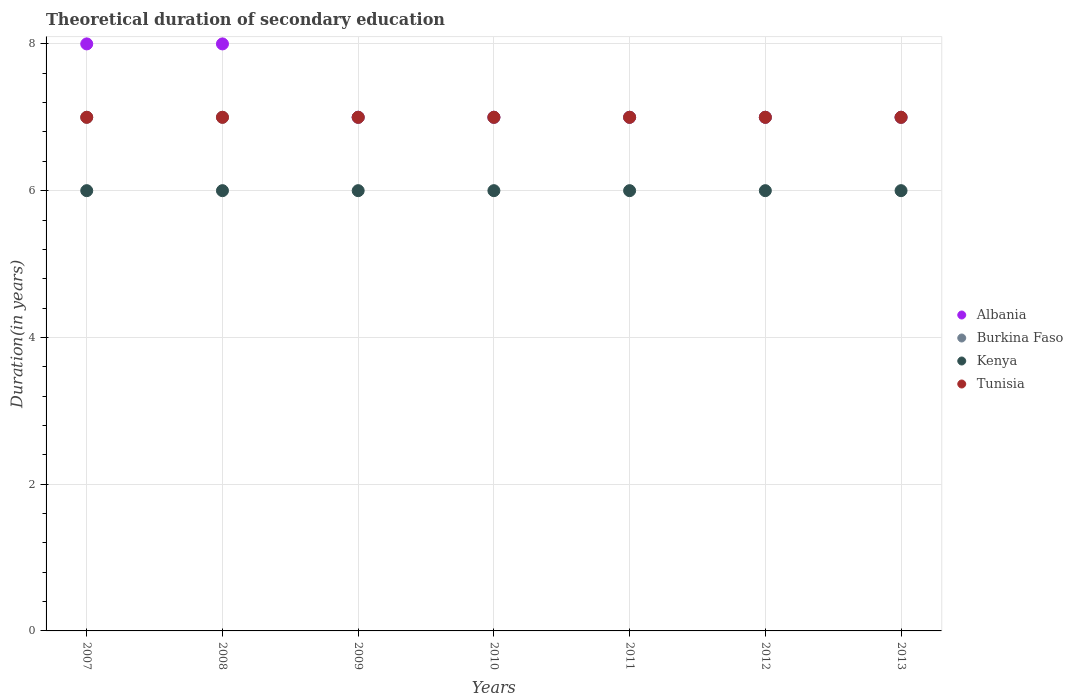What is the total theoretical duration of secondary education in Kenya in 2013?
Provide a short and direct response. 6. Across all years, what is the maximum total theoretical duration of secondary education in Albania?
Offer a very short reply. 8. Across all years, what is the minimum total theoretical duration of secondary education in Tunisia?
Keep it short and to the point. 7. What is the total total theoretical duration of secondary education in Burkina Faso in the graph?
Your answer should be very brief. 49. What is the difference between the total theoretical duration of secondary education in Burkina Faso in 2010 and the total theoretical duration of secondary education in Kenya in 2009?
Your answer should be compact. 1. In the year 2007, what is the difference between the total theoretical duration of secondary education in Tunisia and total theoretical duration of secondary education in Kenya?
Your answer should be compact. 1. In how many years, is the total theoretical duration of secondary education in Kenya greater than 6.4 years?
Offer a very short reply. 0. What is the ratio of the total theoretical duration of secondary education in Albania in 2008 to that in 2009?
Make the answer very short. 1.14. Is the total theoretical duration of secondary education in Kenya in 2008 less than that in 2010?
Your answer should be very brief. No. Is the difference between the total theoretical duration of secondary education in Tunisia in 2008 and 2013 greater than the difference between the total theoretical duration of secondary education in Kenya in 2008 and 2013?
Ensure brevity in your answer.  No. What is the difference between the highest and the second highest total theoretical duration of secondary education in Albania?
Offer a terse response. 0. What is the difference between the highest and the lowest total theoretical duration of secondary education in Tunisia?
Ensure brevity in your answer.  0. Is it the case that in every year, the sum of the total theoretical duration of secondary education in Albania and total theoretical duration of secondary education in Tunisia  is greater than the sum of total theoretical duration of secondary education in Kenya and total theoretical duration of secondary education in Burkina Faso?
Your response must be concise. Yes. Is the total theoretical duration of secondary education in Albania strictly less than the total theoretical duration of secondary education in Burkina Faso over the years?
Make the answer very short. No. How many dotlines are there?
Your answer should be very brief. 4. How many years are there in the graph?
Offer a terse response. 7. Are the values on the major ticks of Y-axis written in scientific E-notation?
Provide a short and direct response. No. Does the graph contain any zero values?
Make the answer very short. No. Does the graph contain grids?
Offer a terse response. Yes. What is the title of the graph?
Offer a very short reply. Theoretical duration of secondary education. What is the label or title of the Y-axis?
Provide a succinct answer. Duration(in years). What is the Duration(in years) in Burkina Faso in 2007?
Make the answer very short. 7. What is the Duration(in years) of Tunisia in 2007?
Provide a succinct answer. 7. What is the Duration(in years) of Albania in 2008?
Offer a very short reply. 8. What is the Duration(in years) of Burkina Faso in 2008?
Your answer should be very brief. 7. What is the Duration(in years) of Kenya in 2008?
Your response must be concise. 6. What is the Duration(in years) of Burkina Faso in 2010?
Offer a terse response. 7. What is the Duration(in years) of Kenya in 2010?
Offer a very short reply. 6. What is the Duration(in years) of Tunisia in 2010?
Provide a short and direct response. 7. What is the Duration(in years) of Burkina Faso in 2011?
Your answer should be compact. 7. What is the Duration(in years) of Burkina Faso in 2012?
Make the answer very short. 7. What is the Duration(in years) in Kenya in 2012?
Make the answer very short. 6. What is the Duration(in years) of Albania in 2013?
Provide a short and direct response. 7. What is the Duration(in years) in Burkina Faso in 2013?
Make the answer very short. 7. What is the Duration(in years) of Kenya in 2013?
Make the answer very short. 6. Across all years, what is the maximum Duration(in years) of Albania?
Provide a succinct answer. 8. Across all years, what is the maximum Duration(in years) in Burkina Faso?
Offer a terse response. 7. Across all years, what is the minimum Duration(in years) of Burkina Faso?
Keep it short and to the point. 7. Across all years, what is the minimum Duration(in years) of Kenya?
Your response must be concise. 6. Across all years, what is the minimum Duration(in years) of Tunisia?
Your response must be concise. 7. What is the total Duration(in years) of Albania in the graph?
Make the answer very short. 51. What is the total Duration(in years) of Tunisia in the graph?
Keep it short and to the point. 49. What is the difference between the Duration(in years) in Tunisia in 2007 and that in 2008?
Give a very brief answer. 0. What is the difference between the Duration(in years) of Burkina Faso in 2007 and that in 2009?
Provide a succinct answer. 0. What is the difference between the Duration(in years) of Kenya in 2007 and that in 2009?
Offer a terse response. 0. What is the difference between the Duration(in years) of Kenya in 2007 and that in 2010?
Keep it short and to the point. 0. What is the difference between the Duration(in years) of Burkina Faso in 2007 and that in 2012?
Your response must be concise. 0. What is the difference between the Duration(in years) of Kenya in 2007 and that in 2012?
Your response must be concise. 0. What is the difference between the Duration(in years) of Albania in 2007 and that in 2013?
Ensure brevity in your answer.  1. What is the difference between the Duration(in years) in Kenya in 2007 and that in 2013?
Your response must be concise. 0. What is the difference between the Duration(in years) in Tunisia in 2007 and that in 2013?
Your answer should be very brief. 0. What is the difference between the Duration(in years) of Albania in 2008 and that in 2009?
Ensure brevity in your answer.  1. What is the difference between the Duration(in years) in Burkina Faso in 2008 and that in 2009?
Ensure brevity in your answer.  0. What is the difference between the Duration(in years) of Tunisia in 2008 and that in 2009?
Your answer should be very brief. 0. What is the difference between the Duration(in years) of Albania in 2008 and that in 2011?
Your answer should be compact. 1. What is the difference between the Duration(in years) of Burkina Faso in 2008 and that in 2011?
Offer a terse response. 0. What is the difference between the Duration(in years) of Kenya in 2008 and that in 2011?
Make the answer very short. 0. What is the difference between the Duration(in years) in Tunisia in 2008 and that in 2011?
Your response must be concise. 0. What is the difference between the Duration(in years) in Albania in 2008 and that in 2012?
Make the answer very short. 1. What is the difference between the Duration(in years) of Burkina Faso in 2008 and that in 2012?
Provide a short and direct response. 0. What is the difference between the Duration(in years) in Kenya in 2008 and that in 2012?
Keep it short and to the point. 0. What is the difference between the Duration(in years) of Tunisia in 2008 and that in 2012?
Your response must be concise. 0. What is the difference between the Duration(in years) of Albania in 2008 and that in 2013?
Offer a terse response. 1. What is the difference between the Duration(in years) in Burkina Faso in 2008 and that in 2013?
Keep it short and to the point. 0. What is the difference between the Duration(in years) of Kenya in 2008 and that in 2013?
Offer a very short reply. 0. What is the difference between the Duration(in years) in Tunisia in 2008 and that in 2013?
Keep it short and to the point. 0. What is the difference between the Duration(in years) in Albania in 2009 and that in 2010?
Your answer should be compact. 0. What is the difference between the Duration(in years) in Burkina Faso in 2009 and that in 2010?
Offer a very short reply. 0. What is the difference between the Duration(in years) in Tunisia in 2009 and that in 2010?
Your response must be concise. 0. What is the difference between the Duration(in years) in Kenya in 2009 and that in 2011?
Ensure brevity in your answer.  0. What is the difference between the Duration(in years) in Tunisia in 2009 and that in 2011?
Make the answer very short. 0. What is the difference between the Duration(in years) of Albania in 2009 and that in 2012?
Provide a short and direct response. 0. What is the difference between the Duration(in years) of Burkina Faso in 2009 and that in 2012?
Offer a terse response. 0. What is the difference between the Duration(in years) in Kenya in 2009 and that in 2012?
Your answer should be compact. 0. What is the difference between the Duration(in years) in Albania in 2009 and that in 2013?
Keep it short and to the point. 0. What is the difference between the Duration(in years) in Tunisia in 2009 and that in 2013?
Your response must be concise. 0. What is the difference between the Duration(in years) of Albania in 2010 and that in 2011?
Make the answer very short. 0. What is the difference between the Duration(in years) in Kenya in 2010 and that in 2011?
Give a very brief answer. 0. What is the difference between the Duration(in years) of Albania in 2010 and that in 2012?
Make the answer very short. 0. What is the difference between the Duration(in years) in Kenya in 2010 and that in 2012?
Give a very brief answer. 0. What is the difference between the Duration(in years) of Tunisia in 2010 and that in 2012?
Your answer should be compact. 0. What is the difference between the Duration(in years) of Albania in 2010 and that in 2013?
Offer a very short reply. 0. What is the difference between the Duration(in years) in Burkina Faso in 2010 and that in 2013?
Keep it short and to the point. 0. What is the difference between the Duration(in years) of Tunisia in 2010 and that in 2013?
Offer a terse response. 0. What is the difference between the Duration(in years) of Albania in 2011 and that in 2012?
Your answer should be compact. 0. What is the difference between the Duration(in years) in Burkina Faso in 2011 and that in 2012?
Your answer should be compact. 0. What is the difference between the Duration(in years) of Tunisia in 2011 and that in 2012?
Offer a very short reply. 0. What is the difference between the Duration(in years) of Albania in 2011 and that in 2013?
Keep it short and to the point. 0. What is the difference between the Duration(in years) in Kenya in 2011 and that in 2013?
Make the answer very short. 0. What is the difference between the Duration(in years) in Burkina Faso in 2012 and that in 2013?
Provide a short and direct response. 0. What is the difference between the Duration(in years) in Albania in 2007 and the Duration(in years) in Burkina Faso in 2008?
Make the answer very short. 1. What is the difference between the Duration(in years) of Burkina Faso in 2007 and the Duration(in years) of Tunisia in 2008?
Offer a terse response. 0. What is the difference between the Duration(in years) of Albania in 2007 and the Duration(in years) of Kenya in 2009?
Your answer should be compact. 2. What is the difference between the Duration(in years) in Burkina Faso in 2007 and the Duration(in years) in Kenya in 2009?
Make the answer very short. 1. What is the difference between the Duration(in years) in Albania in 2007 and the Duration(in years) in Burkina Faso in 2010?
Your answer should be very brief. 1. What is the difference between the Duration(in years) of Albania in 2007 and the Duration(in years) of Kenya in 2010?
Ensure brevity in your answer.  2. What is the difference between the Duration(in years) in Albania in 2007 and the Duration(in years) in Tunisia in 2010?
Your response must be concise. 1. What is the difference between the Duration(in years) of Burkina Faso in 2007 and the Duration(in years) of Kenya in 2010?
Your answer should be compact. 1. What is the difference between the Duration(in years) of Kenya in 2007 and the Duration(in years) of Tunisia in 2010?
Make the answer very short. -1. What is the difference between the Duration(in years) in Albania in 2007 and the Duration(in years) in Burkina Faso in 2011?
Offer a terse response. 1. What is the difference between the Duration(in years) in Albania in 2007 and the Duration(in years) in Kenya in 2011?
Give a very brief answer. 2. What is the difference between the Duration(in years) of Burkina Faso in 2007 and the Duration(in years) of Kenya in 2011?
Offer a terse response. 1. What is the difference between the Duration(in years) of Kenya in 2007 and the Duration(in years) of Tunisia in 2011?
Provide a short and direct response. -1. What is the difference between the Duration(in years) in Albania in 2007 and the Duration(in years) in Burkina Faso in 2012?
Ensure brevity in your answer.  1. What is the difference between the Duration(in years) of Albania in 2007 and the Duration(in years) of Kenya in 2012?
Provide a short and direct response. 2. What is the difference between the Duration(in years) of Albania in 2007 and the Duration(in years) of Tunisia in 2012?
Provide a short and direct response. 1. What is the difference between the Duration(in years) in Burkina Faso in 2007 and the Duration(in years) in Kenya in 2012?
Offer a terse response. 1. What is the difference between the Duration(in years) of Albania in 2007 and the Duration(in years) of Burkina Faso in 2013?
Your response must be concise. 1. What is the difference between the Duration(in years) in Kenya in 2007 and the Duration(in years) in Tunisia in 2013?
Provide a short and direct response. -1. What is the difference between the Duration(in years) in Albania in 2008 and the Duration(in years) in Kenya in 2009?
Make the answer very short. 2. What is the difference between the Duration(in years) of Albania in 2008 and the Duration(in years) of Tunisia in 2009?
Give a very brief answer. 1. What is the difference between the Duration(in years) in Burkina Faso in 2008 and the Duration(in years) in Tunisia in 2009?
Provide a succinct answer. 0. What is the difference between the Duration(in years) in Albania in 2008 and the Duration(in years) in Burkina Faso in 2010?
Provide a short and direct response. 1. What is the difference between the Duration(in years) in Burkina Faso in 2008 and the Duration(in years) in Kenya in 2010?
Offer a terse response. 1. What is the difference between the Duration(in years) in Kenya in 2008 and the Duration(in years) in Tunisia in 2010?
Your answer should be very brief. -1. What is the difference between the Duration(in years) of Albania in 2008 and the Duration(in years) of Kenya in 2011?
Make the answer very short. 2. What is the difference between the Duration(in years) in Burkina Faso in 2008 and the Duration(in years) in Kenya in 2011?
Offer a very short reply. 1. What is the difference between the Duration(in years) in Albania in 2008 and the Duration(in years) in Kenya in 2012?
Your answer should be very brief. 2. What is the difference between the Duration(in years) of Kenya in 2008 and the Duration(in years) of Tunisia in 2012?
Provide a succinct answer. -1. What is the difference between the Duration(in years) in Albania in 2008 and the Duration(in years) in Tunisia in 2013?
Make the answer very short. 1. What is the difference between the Duration(in years) of Kenya in 2008 and the Duration(in years) of Tunisia in 2013?
Offer a terse response. -1. What is the difference between the Duration(in years) of Albania in 2009 and the Duration(in years) of Kenya in 2010?
Keep it short and to the point. 1. What is the difference between the Duration(in years) in Albania in 2009 and the Duration(in years) in Tunisia in 2010?
Offer a terse response. 0. What is the difference between the Duration(in years) in Burkina Faso in 2009 and the Duration(in years) in Tunisia in 2010?
Your response must be concise. 0. What is the difference between the Duration(in years) in Albania in 2009 and the Duration(in years) in Burkina Faso in 2011?
Your answer should be very brief. 0. What is the difference between the Duration(in years) of Albania in 2009 and the Duration(in years) of Kenya in 2011?
Give a very brief answer. 1. What is the difference between the Duration(in years) of Burkina Faso in 2009 and the Duration(in years) of Kenya in 2011?
Provide a succinct answer. 1. What is the difference between the Duration(in years) of Burkina Faso in 2009 and the Duration(in years) of Tunisia in 2011?
Your answer should be compact. 0. What is the difference between the Duration(in years) of Kenya in 2009 and the Duration(in years) of Tunisia in 2011?
Your answer should be very brief. -1. What is the difference between the Duration(in years) of Albania in 2009 and the Duration(in years) of Kenya in 2012?
Your response must be concise. 1. What is the difference between the Duration(in years) of Albania in 2009 and the Duration(in years) of Tunisia in 2012?
Offer a very short reply. 0. What is the difference between the Duration(in years) of Burkina Faso in 2009 and the Duration(in years) of Tunisia in 2012?
Your answer should be compact. 0. What is the difference between the Duration(in years) of Albania in 2009 and the Duration(in years) of Burkina Faso in 2013?
Your answer should be very brief. 0. What is the difference between the Duration(in years) in Albania in 2009 and the Duration(in years) in Tunisia in 2013?
Keep it short and to the point. 0. What is the difference between the Duration(in years) of Burkina Faso in 2009 and the Duration(in years) of Kenya in 2013?
Offer a very short reply. 1. What is the difference between the Duration(in years) of Burkina Faso in 2009 and the Duration(in years) of Tunisia in 2013?
Provide a short and direct response. 0. What is the difference between the Duration(in years) in Albania in 2010 and the Duration(in years) in Burkina Faso in 2011?
Provide a short and direct response. 0. What is the difference between the Duration(in years) of Albania in 2010 and the Duration(in years) of Kenya in 2011?
Provide a succinct answer. 1. What is the difference between the Duration(in years) of Burkina Faso in 2010 and the Duration(in years) of Tunisia in 2011?
Ensure brevity in your answer.  0. What is the difference between the Duration(in years) of Albania in 2010 and the Duration(in years) of Burkina Faso in 2012?
Keep it short and to the point. 0. What is the difference between the Duration(in years) of Burkina Faso in 2010 and the Duration(in years) of Tunisia in 2012?
Your response must be concise. 0. What is the difference between the Duration(in years) in Albania in 2010 and the Duration(in years) in Burkina Faso in 2013?
Your answer should be compact. 0. What is the difference between the Duration(in years) of Burkina Faso in 2010 and the Duration(in years) of Kenya in 2013?
Provide a short and direct response. 1. What is the difference between the Duration(in years) in Burkina Faso in 2010 and the Duration(in years) in Tunisia in 2013?
Ensure brevity in your answer.  0. What is the difference between the Duration(in years) of Albania in 2011 and the Duration(in years) of Burkina Faso in 2012?
Make the answer very short. 0. What is the difference between the Duration(in years) in Albania in 2011 and the Duration(in years) in Tunisia in 2012?
Ensure brevity in your answer.  0. What is the difference between the Duration(in years) in Burkina Faso in 2011 and the Duration(in years) in Kenya in 2012?
Your response must be concise. 1. What is the difference between the Duration(in years) of Burkina Faso in 2011 and the Duration(in years) of Tunisia in 2012?
Your answer should be compact. 0. What is the difference between the Duration(in years) in Albania in 2011 and the Duration(in years) in Tunisia in 2013?
Provide a short and direct response. 0. What is the difference between the Duration(in years) in Burkina Faso in 2011 and the Duration(in years) in Tunisia in 2013?
Provide a succinct answer. 0. What is the difference between the Duration(in years) of Albania in 2012 and the Duration(in years) of Burkina Faso in 2013?
Your answer should be very brief. 0. What is the difference between the Duration(in years) in Albania in 2012 and the Duration(in years) in Kenya in 2013?
Make the answer very short. 1. What is the difference between the Duration(in years) of Burkina Faso in 2012 and the Duration(in years) of Tunisia in 2013?
Provide a succinct answer. 0. What is the difference between the Duration(in years) in Kenya in 2012 and the Duration(in years) in Tunisia in 2013?
Your answer should be very brief. -1. What is the average Duration(in years) in Albania per year?
Provide a short and direct response. 7.29. What is the average Duration(in years) in Burkina Faso per year?
Your response must be concise. 7. What is the average Duration(in years) in Tunisia per year?
Provide a succinct answer. 7. In the year 2007, what is the difference between the Duration(in years) in Albania and Duration(in years) in Kenya?
Ensure brevity in your answer.  2. In the year 2007, what is the difference between the Duration(in years) in Albania and Duration(in years) in Tunisia?
Ensure brevity in your answer.  1. In the year 2007, what is the difference between the Duration(in years) of Burkina Faso and Duration(in years) of Kenya?
Your answer should be compact. 1. In the year 2008, what is the difference between the Duration(in years) of Albania and Duration(in years) of Burkina Faso?
Your answer should be very brief. 1. In the year 2008, what is the difference between the Duration(in years) of Albania and Duration(in years) of Tunisia?
Offer a terse response. 1. In the year 2008, what is the difference between the Duration(in years) of Burkina Faso and Duration(in years) of Kenya?
Your answer should be compact. 1. In the year 2008, what is the difference between the Duration(in years) in Burkina Faso and Duration(in years) in Tunisia?
Offer a very short reply. 0. In the year 2009, what is the difference between the Duration(in years) in Albania and Duration(in years) in Kenya?
Your answer should be compact. 1. In the year 2009, what is the difference between the Duration(in years) in Burkina Faso and Duration(in years) in Kenya?
Your answer should be compact. 1. In the year 2009, what is the difference between the Duration(in years) of Burkina Faso and Duration(in years) of Tunisia?
Offer a very short reply. 0. In the year 2009, what is the difference between the Duration(in years) in Kenya and Duration(in years) in Tunisia?
Your answer should be compact. -1. In the year 2010, what is the difference between the Duration(in years) in Albania and Duration(in years) in Burkina Faso?
Offer a terse response. 0. In the year 2010, what is the difference between the Duration(in years) in Burkina Faso and Duration(in years) in Kenya?
Keep it short and to the point. 1. In the year 2011, what is the difference between the Duration(in years) of Albania and Duration(in years) of Burkina Faso?
Your answer should be compact. 0. In the year 2011, what is the difference between the Duration(in years) of Albania and Duration(in years) of Kenya?
Offer a very short reply. 1. In the year 2011, what is the difference between the Duration(in years) of Albania and Duration(in years) of Tunisia?
Offer a very short reply. 0. In the year 2012, what is the difference between the Duration(in years) of Albania and Duration(in years) of Kenya?
Make the answer very short. 1. In the year 2012, what is the difference between the Duration(in years) of Albania and Duration(in years) of Tunisia?
Make the answer very short. 0. In the year 2012, what is the difference between the Duration(in years) of Burkina Faso and Duration(in years) of Kenya?
Your response must be concise. 1. In the year 2012, what is the difference between the Duration(in years) of Kenya and Duration(in years) of Tunisia?
Provide a succinct answer. -1. In the year 2013, what is the difference between the Duration(in years) in Albania and Duration(in years) in Burkina Faso?
Your response must be concise. 0. In the year 2013, what is the difference between the Duration(in years) of Albania and Duration(in years) of Kenya?
Keep it short and to the point. 1. In the year 2013, what is the difference between the Duration(in years) of Burkina Faso and Duration(in years) of Tunisia?
Keep it short and to the point. 0. What is the ratio of the Duration(in years) in Tunisia in 2007 to that in 2008?
Make the answer very short. 1. What is the ratio of the Duration(in years) of Burkina Faso in 2007 to that in 2009?
Provide a succinct answer. 1. What is the ratio of the Duration(in years) of Kenya in 2007 to that in 2009?
Provide a short and direct response. 1. What is the ratio of the Duration(in years) in Tunisia in 2007 to that in 2009?
Give a very brief answer. 1. What is the ratio of the Duration(in years) in Burkina Faso in 2007 to that in 2010?
Make the answer very short. 1. What is the ratio of the Duration(in years) in Tunisia in 2007 to that in 2010?
Your response must be concise. 1. What is the ratio of the Duration(in years) of Tunisia in 2007 to that in 2011?
Your answer should be very brief. 1. What is the ratio of the Duration(in years) in Burkina Faso in 2007 to that in 2012?
Ensure brevity in your answer.  1. What is the ratio of the Duration(in years) of Albania in 2007 to that in 2013?
Keep it short and to the point. 1.14. What is the ratio of the Duration(in years) of Kenya in 2007 to that in 2013?
Give a very brief answer. 1. What is the ratio of the Duration(in years) in Tunisia in 2007 to that in 2013?
Your response must be concise. 1. What is the ratio of the Duration(in years) of Burkina Faso in 2008 to that in 2009?
Ensure brevity in your answer.  1. What is the ratio of the Duration(in years) in Albania in 2008 to that in 2011?
Make the answer very short. 1.14. What is the ratio of the Duration(in years) in Burkina Faso in 2008 to that in 2011?
Provide a short and direct response. 1. What is the ratio of the Duration(in years) of Kenya in 2008 to that in 2011?
Your answer should be very brief. 1. What is the ratio of the Duration(in years) of Albania in 2008 to that in 2012?
Offer a terse response. 1.14. What is the ratio of the Duration(in years) in Kenya in 2008 to that in 2012?
Give a very brief answer. 1. What is the ratio of the Duration(in years) in Tunisia in 2008 to that in 2012?
Provide a short and direct response. 1. What is the ratio of the Duration(in years) in Albania in 2008 to that in 2013?
Ensure brevity in your answer.  1.14. What is the ratio of the Duration(in years) in Tunisia in 2008 to that in 2013?
Provide a succinct answer. 1. What is the ratio of the Duration(in years) in Albania in 2009 to that in 2010?
Ensure brevity in your answer.  1. What is the ratio of the Duration(in years) of Tunisia in 2009 to that in 2011?
Provide a succinct answer. 1. What is the ratio of the Duration(in years) in Albania in 2009 to that in 2012?
Ensure brevity in your answer.  1. What is the ratio of the Duration(in years) of Tunisia in 2009 to that in 2012?
Make the answer very short. 1. What is the ratio of the Duration(in years) in Albania in 2009 to that in 2013?
Keep it short and to the point. 1. What is the ratio of the Duration(in years) in Albania in 2010 to that in 2011?
Your response must be concise. 1. What is the ratio of the Duration(in years) of Burkina Faso in 2010 to that in 2011?
Offer a terse response. 1. What is the ratio of the Duration(in years) of Albania in 2010 to that in 2012?
Offer a terse response. 1. What is the ratio of the Duration(in years) of Burkina Faso in 2010 to that in 2012?
Ensure brevity in your answer.  1. What is the ratio of the Duration(in years) of Kenya in 2010 to that in 2012?
Your response must be concise. 1. What is the ratio of the Duration(in years) in Tunisia in 2010 to that in 2012?
Make the answer very short. 1. What is the ratio of the Duration(in years) of Burkina Faso in 2010 to that in 2013?
Ensure brevity in your answer.  1. What is the ratio of the Duration(in years) in Tunisia in 2010 to that in 2013?
Give a very brief answer. 1. What is the ratio of the Duration(in years) in Kenya in 2011 to that in 2012?
Ensure brevity in your answer.  1. What is the ratio of the Duration(in years) in Tunisia in 2011 to that in 2012?
Your response must be concise. 1. What is the ratio of the Duration(in years) in Tunisia in 2011 to that in 2013?
Give a very brief answer. 1. What is the ratio of the Duration(in years) in Burkina Faso in 2012 to that in 2013?
Provide a short and direct response. 1. What is the ratio of the Duration(in years) in Kenya in 2012 to that in 2013?
Your answer should be very brief. 1. What is the ratio of the Duration(in years) of Tunisia in 2012 to that in 2013?
Make the answer very short. 1. What is the difference between the highest and the lowest Duration(in years) in Kenya?
Your answer should be very brief. 0. What is the difference between the highest and the lowest Duration(in years) of Tunisia?
Your answer should be compact. 0. 